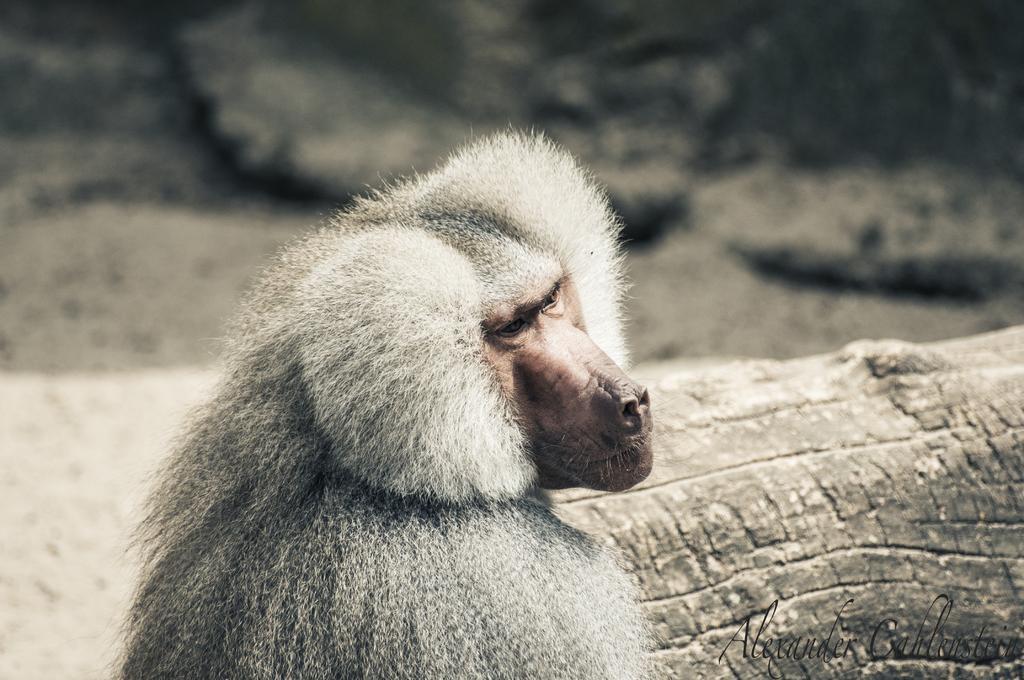How would you summarize this image in a sentence or two? In the center of the image, we can see an animal and there is a log. In the background, there are rocks and at the bottom, there is some text. 